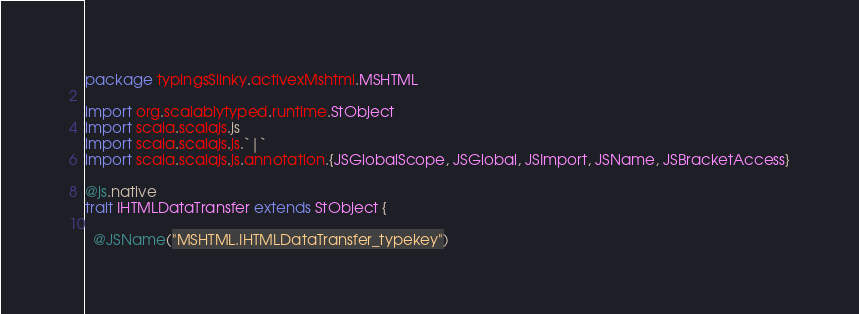Convert code to text. <code><loc_0><loc_0><loc_500><loc_500><_Scala_>package typingsSlinky.activexMshtml.MSHTML

import org.scalablytyped.runtime.StObject
import scala.scalajs.js
import scala.scalajs.js.`|`
import scala.scalajs.js.annotation.{JSGlobalScope, JSGlobal, JSImport, JSName, JSBracketAccess}

@js.native
trait IHTMLDataTransfer extends StObject {
  
  @JSName("MSHTML.IHTMLDataTransfer_typekey")</code> 